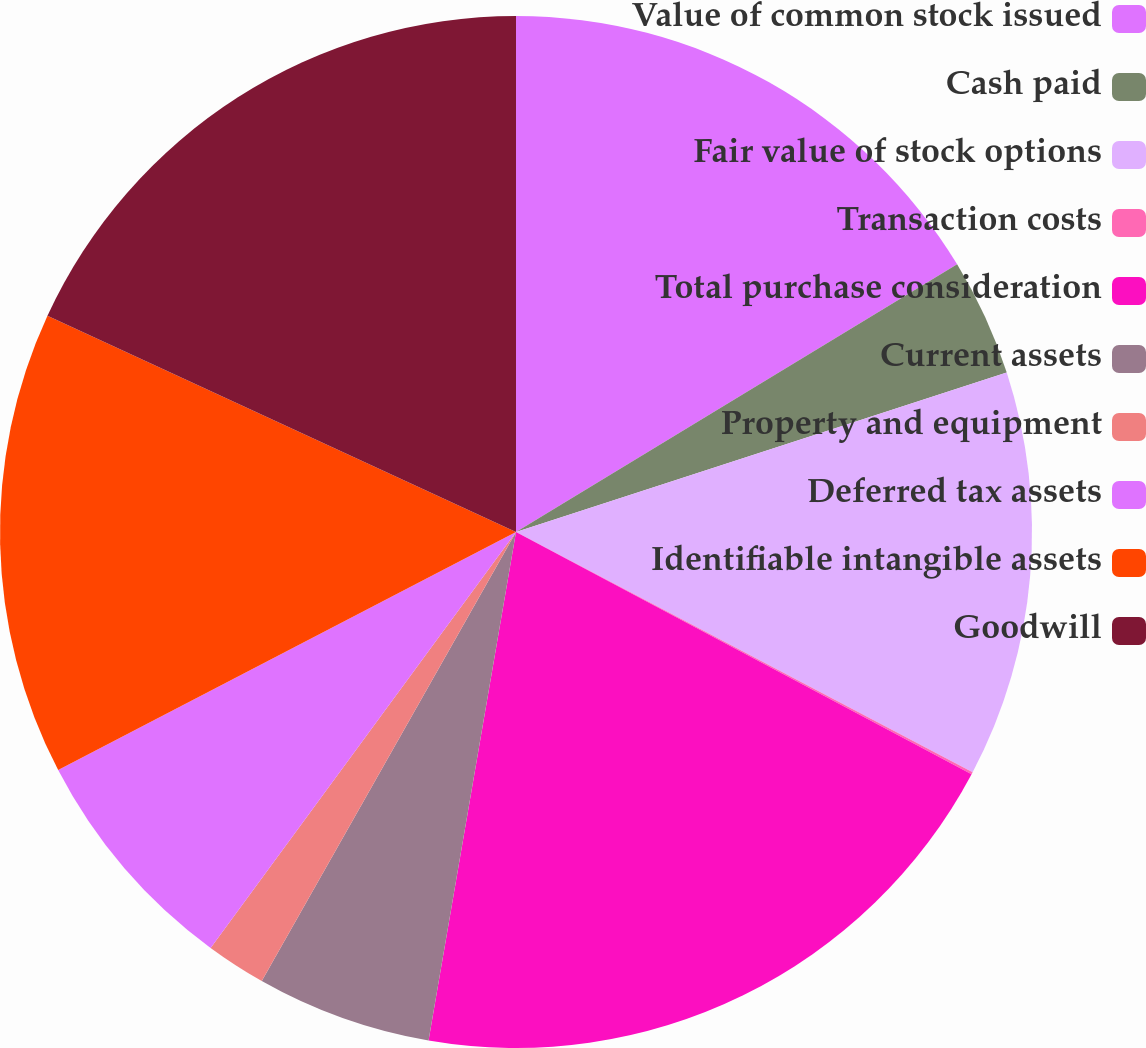Convert chart to OTSL. <chart><loc_0><loc_0><loc_500><loc_500><pie_chart><fcel>Value of common stock issued<fcel>Cash paid<fcel>Fair value of stock options<fcel>Transaction costs<fcel>Total purchase consideration<fcel>Current assets<fcel>Property and equipment<fcel>Deferred tax assets<fcel>Identifiable intangible assets<fcel>Goodwill<nl><fcel>16.32%<fcel>3.68%<fcel>12.71%<fcel>0.07%<fcel>19.93%<fcel>5.49%<fcel>1.88%<fcel>7.29%<fcel>14.51%<fcel>18.12%<nl></chart> 